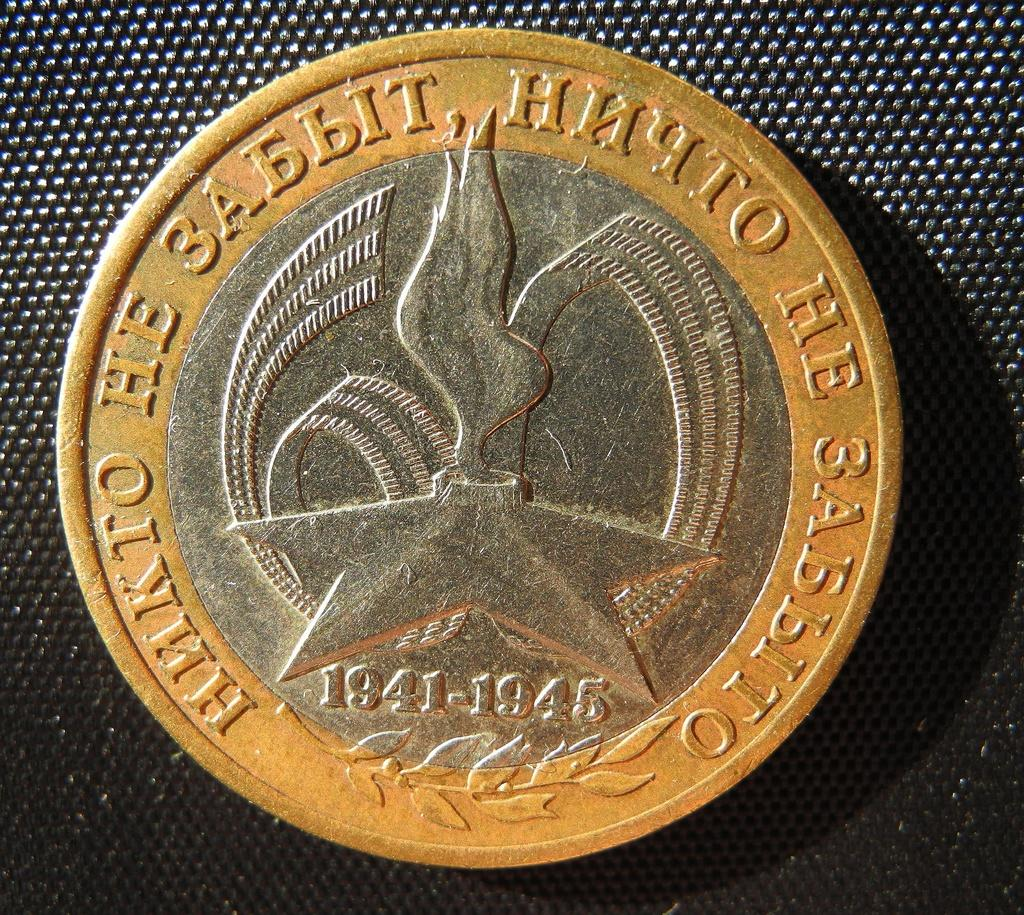<image>
Present a compact description of the photo's key features. A gold and silver coin with has a date 1941-1945. 